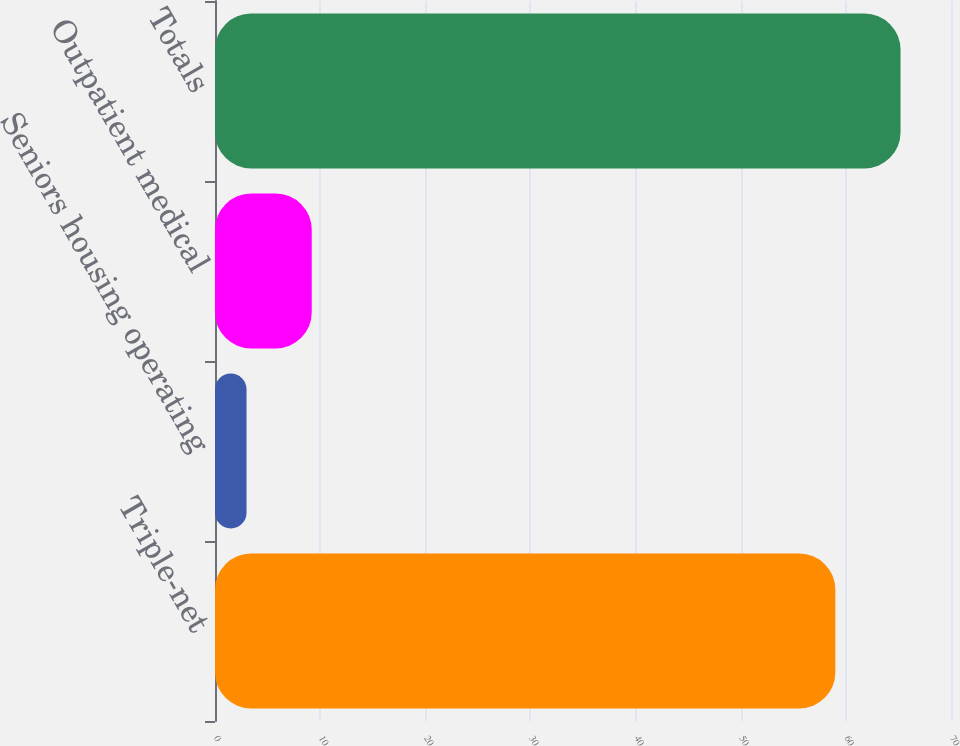Convert chart. <chart><loc_0><loc_0><loc_500><loc_500><bar_chart><fcel>Triple-net<fcel>Seniors housing operating<fcel>Outpatient medical<fcel>Totals<nl><fcel>59<fcel>3<fcel>9.2<fcel>65.2<nl></chart> 